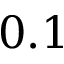Convert formula to latex. <formula><loc_0><loc_0><loc_500><loc_500>0 . 1</formula> 